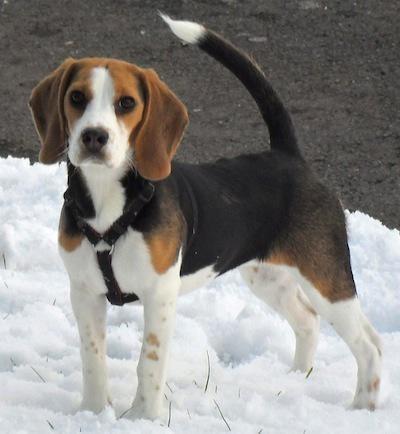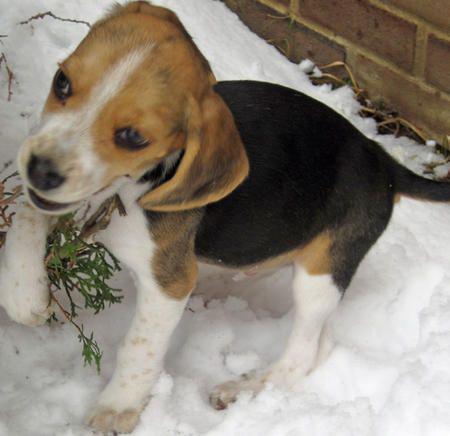The first image is the image on the left, the second image is the image on the right. Assess this claim about the two images: "All dogs are looking up at the camera, at least one dog has an open mouth, and no image contains more than two dogs.". Correct or not? Answer yes or no. No. The first image is the image on the left, the second image is the image on the right. For the images shown, is this caption "There are at least two dogs in the left image." true? Answer yes or no. No. 